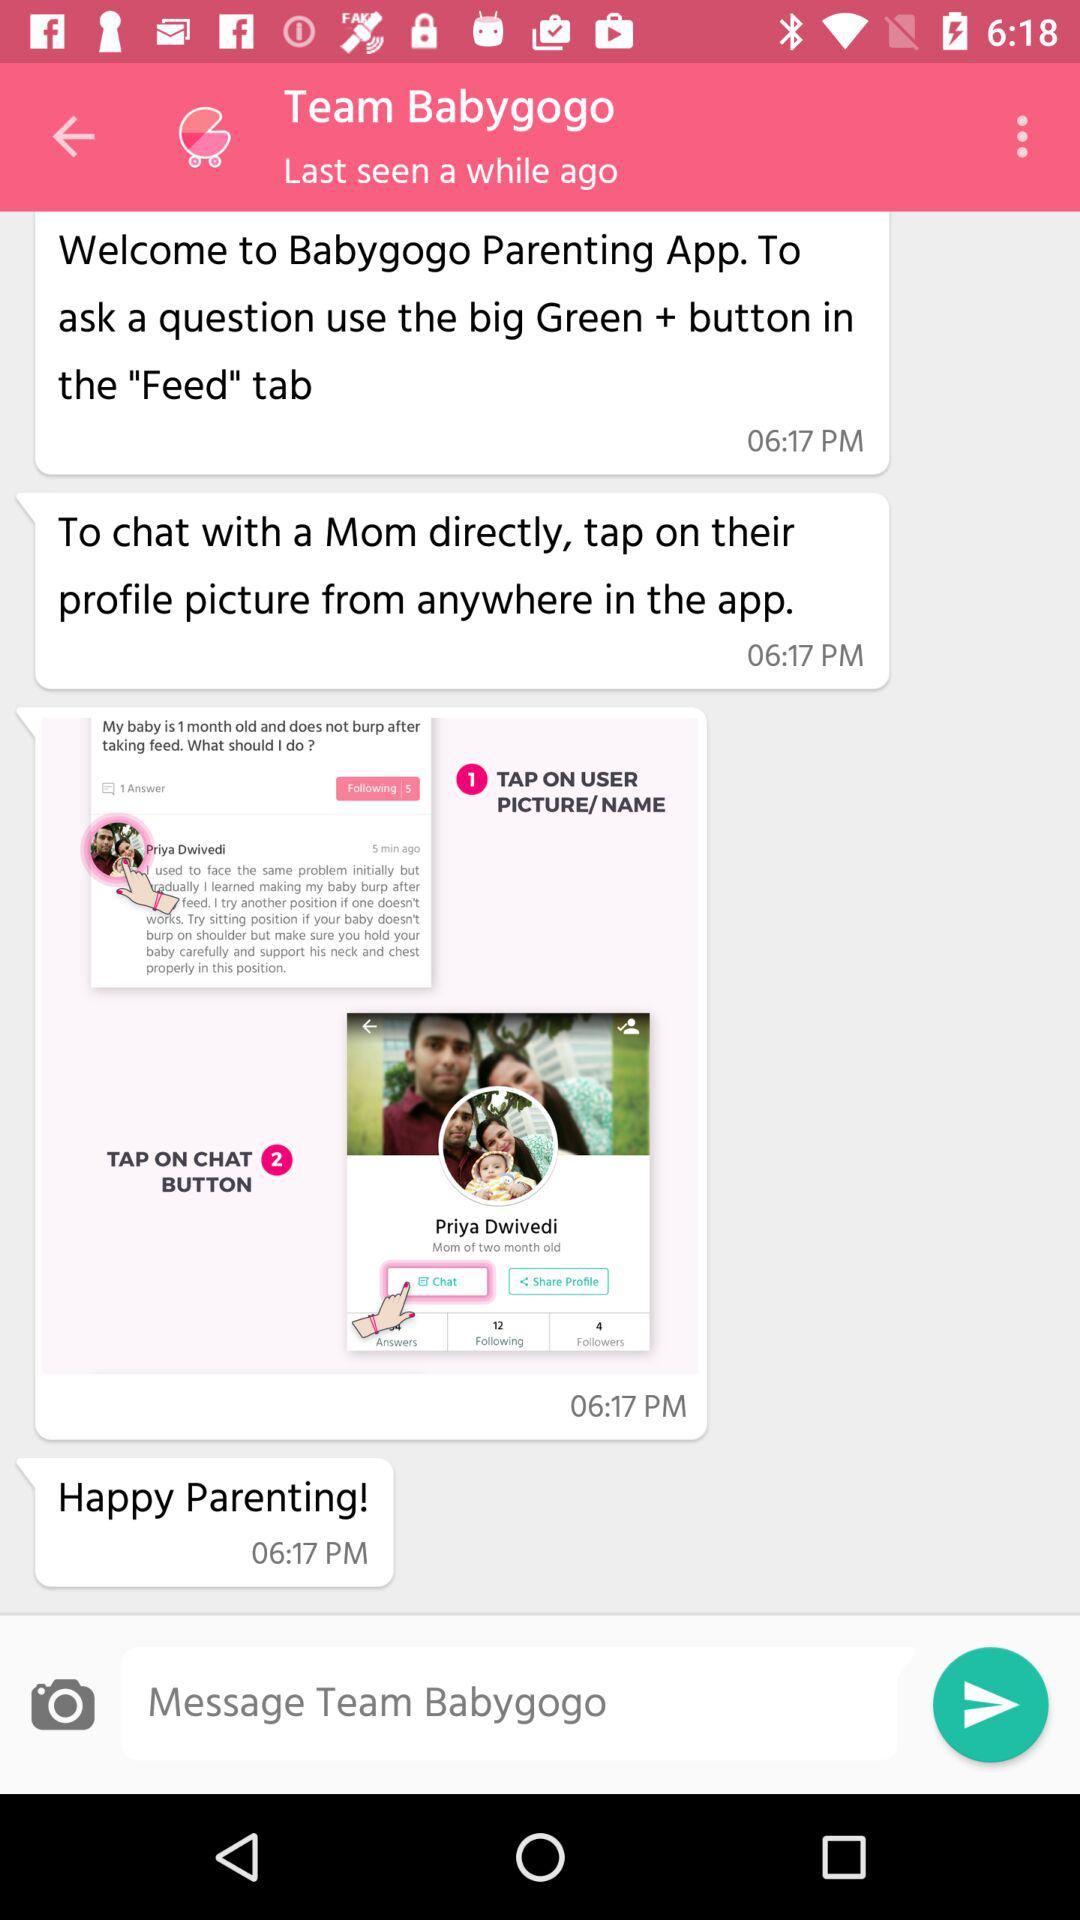At what time was the message "Happy Parenting!" received? The message "Happy Parenting!" was received at 6:17 p.m. 